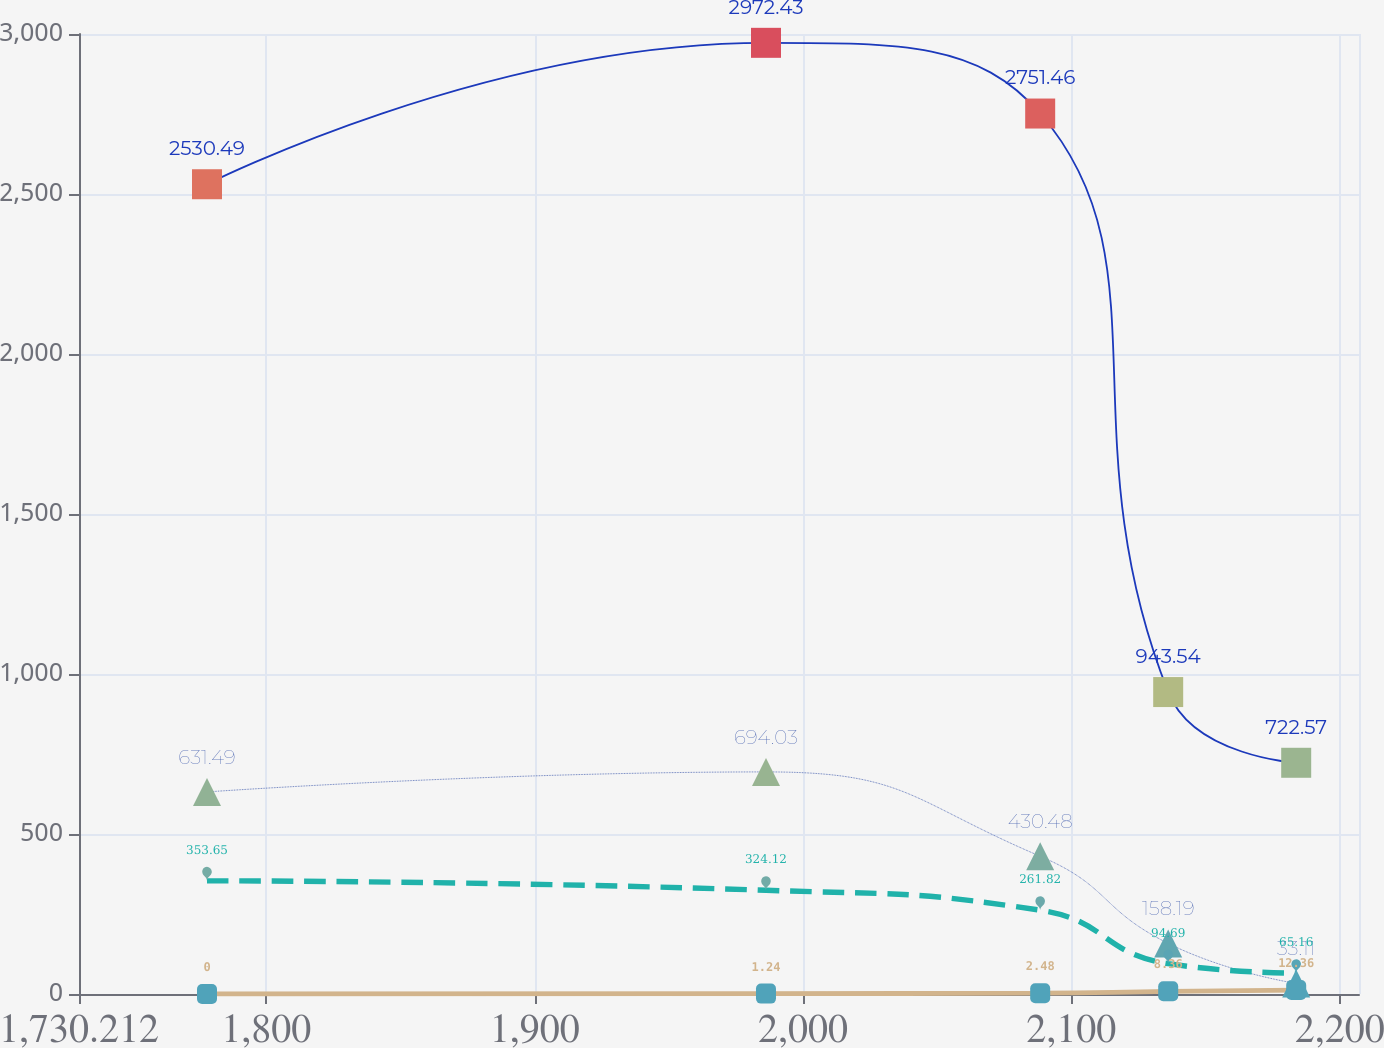Convert chart to OTSL. <chart><loc_0><loc_0><loc_500><loc_500><line_chart><ecel><fcel>Consumer International<fcel>Corporate (3)<fcel>SPD<fcel>Total<nl><fcel>1777.91<fcel>2530.49<fcel>631.49<fcel>353.65<fcel>0<nl><fcel>1986.21<fcel>2972.43<fcel>694.03<fcel>324.12<fcel>1.24<nl><fcel>2088.39<fcel>2751.46<fcel>430.48<fcel>261.82<fcel>2.48<nl><fcel>2136.09<fcel>943.54<fcel>158.19<fcel>94.69<fcel>8.36<nl><fcel>2183.79<fcel>722.57<fcel>33.11<fcel>65.16<fcel>12.36<nl><fcel>2254.89<fcel>501.6<fcel>95.65<fcel>35.63<fcel>10.77<nl></chart> 